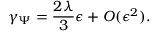<formula> <loc_0><loc_0><loc_500><loc_500>\gamma _ { \Psi } = \frac { 2 \lambda } { 3 } \epsilon + O ( \epsilon ^ { 2 } ) .</formula> 